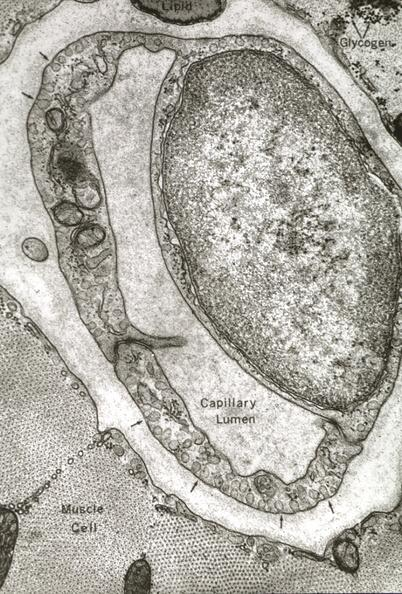s subdiaphragmatic abscess present?
Answer the question using a single word or phrase. No 